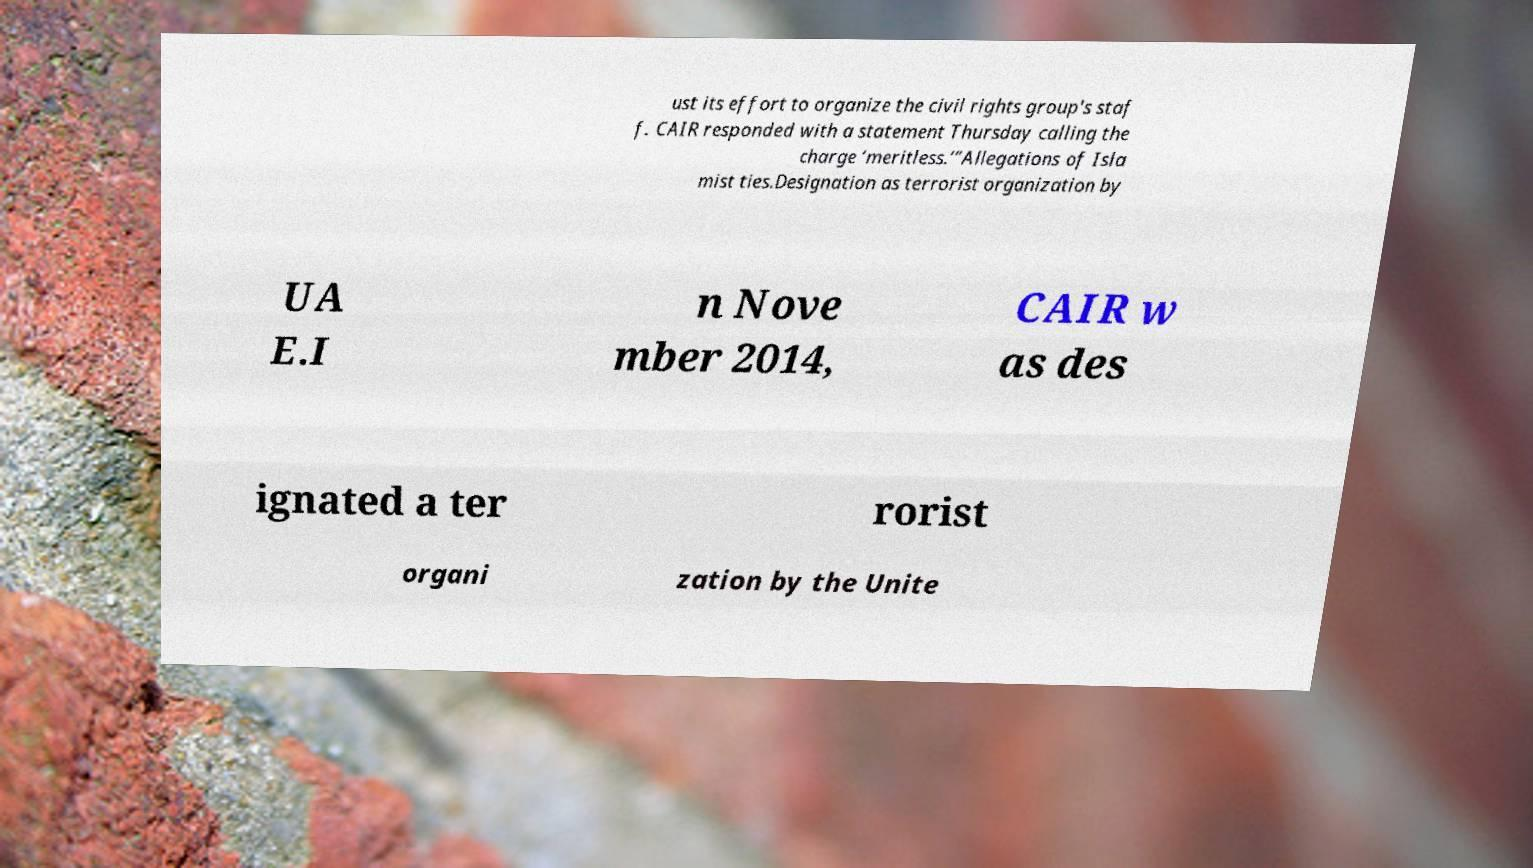Please read and relay the text visible in this image. What does it say? ust its effort to organize the civil rights group's staf f. CAIR responded with a statement Thursday calling the charge ‘meritless.’”Allegations of Isla mist ties.Designation as terrorist organization by UA E.I n Nove mber 2014, CAIR w as des ignated a ter rorist organi zation by the Unite 